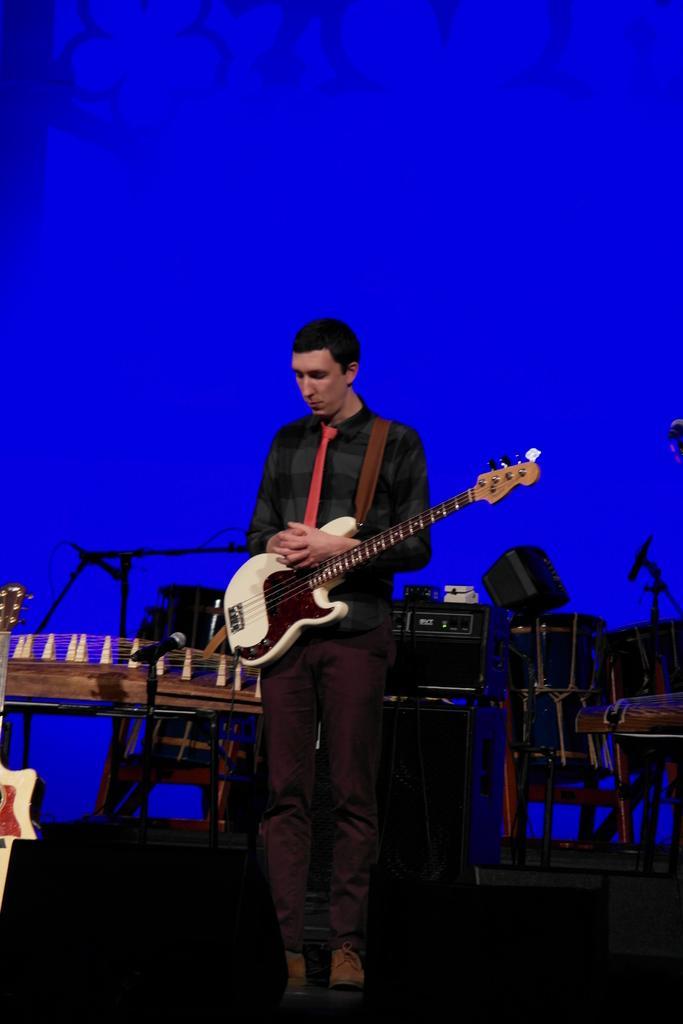How would you summarize this image in a sentence or two? In this picture only one person is present standing in the middle wearing a red tie and shirt, pant and holding a white guitar and behind him there are drums, keyboard and some other instruments. Where the backside is blue in colour. 